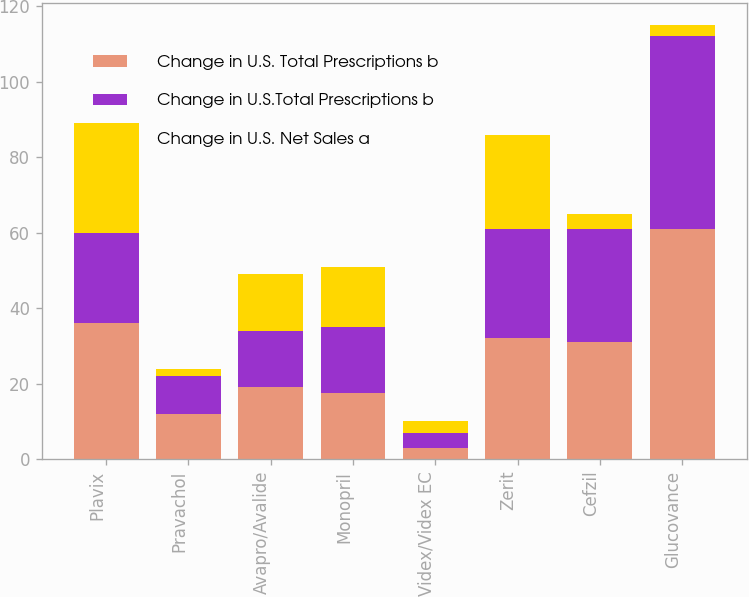Convert chart. <chart><loc_0><loc_0><loc_500><loc_500><stacked_bar_chart><ecel><fcel>Plavix<fcel>Pravachol<fcel>Avapro/Avalide<fcel>Monopril<fcel>Videx/Videx EC<fcel>Zerit<fcel>Cefzil<fcel>Glucovance<nl><fcel>Change in U.S. Total Prescriptions b<fcel>36<fcel>12<fcel>19<fcel>17.5<fcel>3<fcel>32<fcel>31<fcel>61<nl><fcel>Change in U.S.Total Prescriptions b<fcel>24<fcel>10<fcel>15<fcel>17.5<fcel>4<fcel>29<fcel>30<fcel>51<nl><fcel>Change in U.S. Net Sales a<fcel>29<fcel>2<fcel>15<fcel>16<fcel>3<fcel>25<fcel>4<fcel>3<nl></chart> 